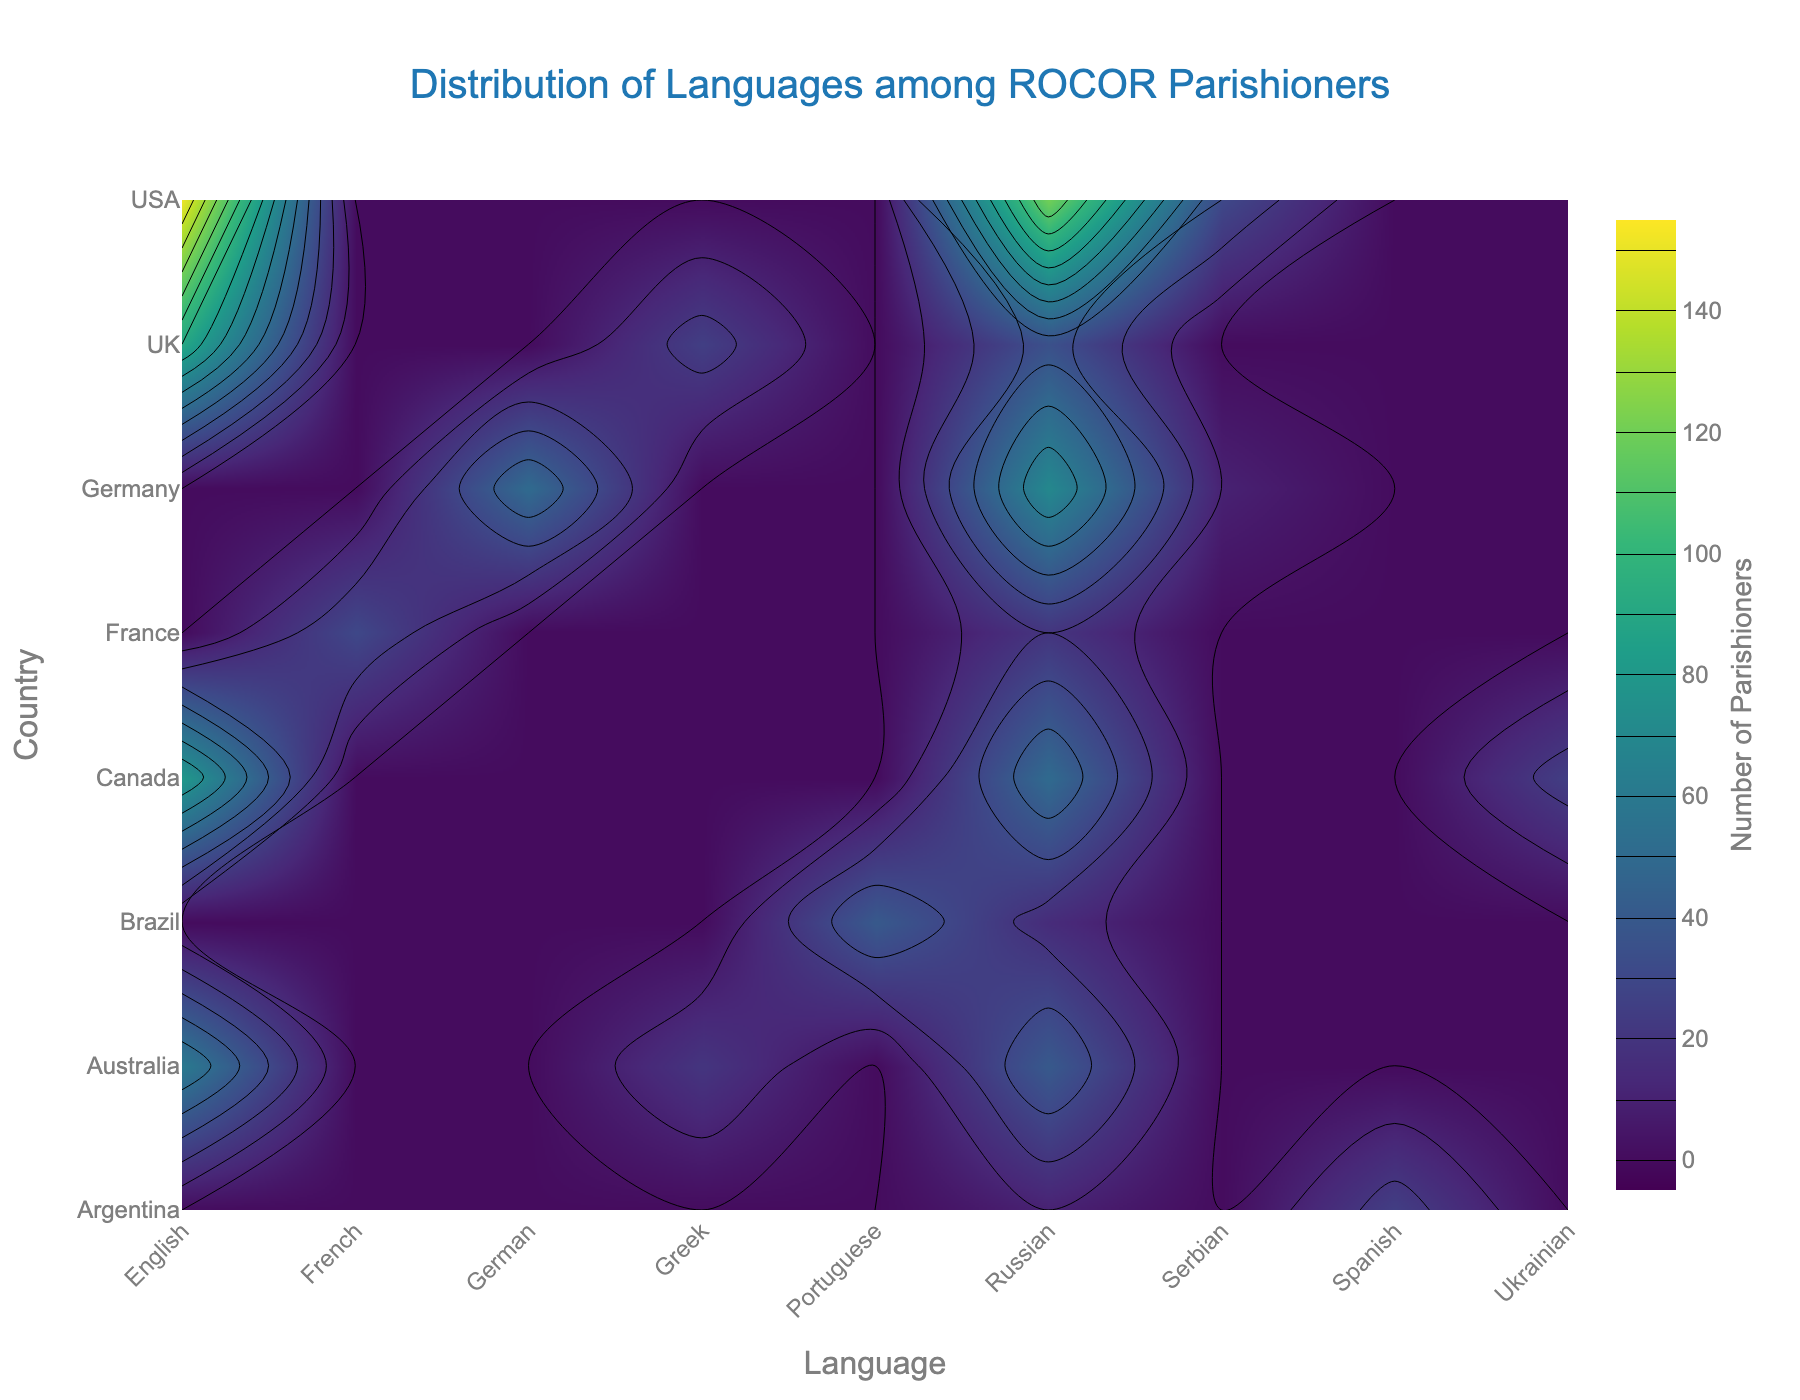what is the title of the figure? The title of a plot is usually displayed at the top of the figure and should be easily readable. In this case, it reads "Distribution of Languages among ROCOR Parishioners."
Answer: Distribution of Languages among ROCOR Parishioners Which country has the highest number of English-speaking parishioners? Locate the 'English' column on the x-axis and find the highest z-value point along that column. USA is the country with the highest number, marked by the peak value around 150.
Answer: USA How many languages are spoken in Canada according to the plot? Look at the contour levels for the y-axis labeled 'Canada.' Counting distinct x-values that intersect with Canada will show the number of different languages spoken.
Answer: 3 Which country has the smallest number of Russian-speaking parishioners? Locate the 'Russian' column and identify the smallest contour level within that column. Argentina, which is near the lowest value, has the smallest number with only 10 Russian-speaking parishioners.
Answer: Argentina Compare the number of parishioners speaking Greek in the UK and Australia. Which country has more? Identify the levels in the 'Greek' column for both UK and Australia. The UK has a level of 25, while Australia has a level of 20, showing that the UK has more Greek-speaking parishioners.
Answer: UK How many parishioners speak languages other than English in the USA? Look at the USA row and sum the values for the languages except English (Russian and Serbian). The values are 120 for Russian and 30 for Serbian, making a total of 150.
Answer: 150 Which language has the highest number of parishioners in Germany? Identify the highest contour level within the row labeled 'Germany'. Russian has the peak level of 70 parishioners, higher than German (50) and Serbian (10).
Answer: Russian What is the total number of English-speaking parishioners across all countries? Sum the contour values in the 'English' column. Values are 150 (USA), 80 (Canada), 60 (Australia), and 90 (UK). Therefore, the total is 380.
Answer: 380 Is there a country where more than two languages are spoken by parishioners? Examine each country's row to find where more than two columns have non-zero values. The USA, Canada, Australia, Germany, and the UK each have three languages spoken.
Answer: Yes Which has more Ukrainian-speaking parishioners: Canada or the USA? Cross-check values for 'Ukrainian' in applicable countries. Only Canada shows a non-zero contour, with 25 parishioners. The USA has zero Ukrainian-speaking parishioners
Answer: Canada 